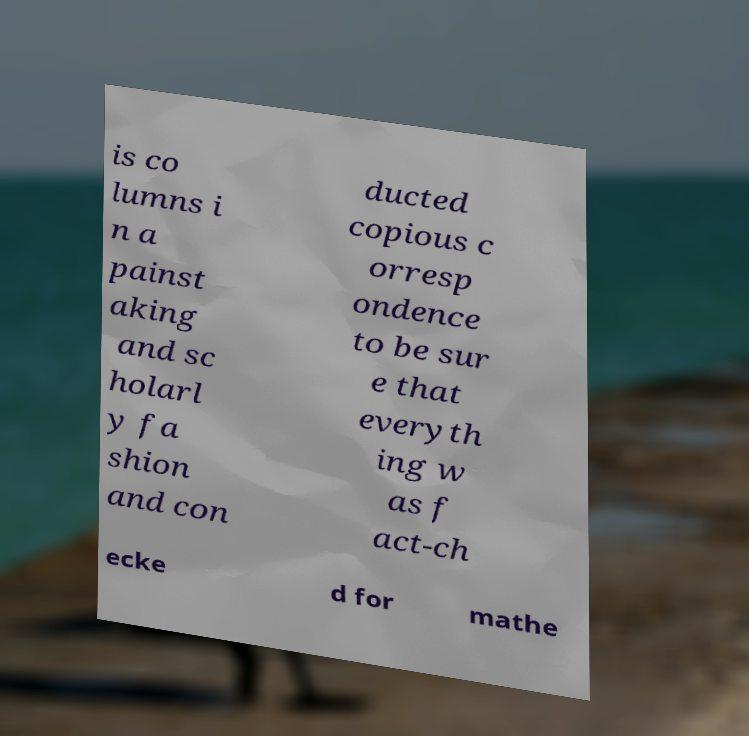Please read and relay the text visible in this image. What does it say? is co lumns i n a painst aking and sc holarl y fa shion and con ducted copious c orresp ondence to be sur e that everyth ing w as f act-ch ecke d for mathe 